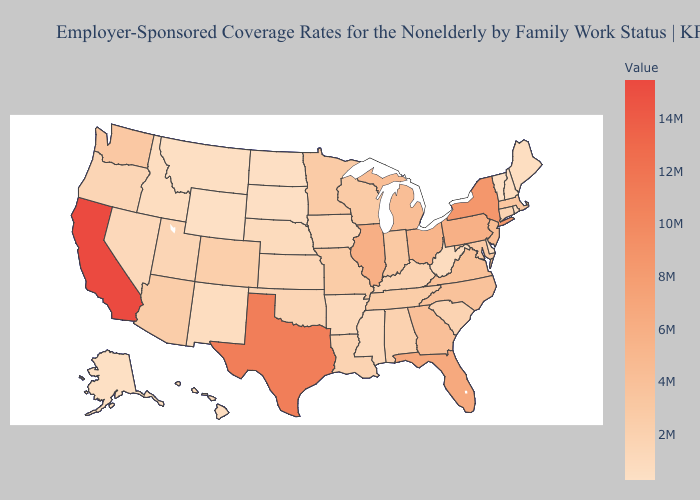Does Colorado have the highest value in the USA?
Be succinct. No. Does Hawaii have the highest value in the USA?
Be succinct. No. Does Maryland have a lower value than Ohio?
Short answer required. Yes. Is the legend a continuous bar?
Concise answer only. Yes. Which states have the lowest value in the MidWest?
Be succinct. North Dakota. Does New York have the highest value in the USA?
Give a very brief answer. No. Which states have the highest value in the USA?
Write a very short answer. California. 